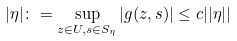Convert formula to latex. <formula><loc_0><loc_0><loc_500><loc_500>| \eta | \colon = \sup _ { z \in U , s \in S _ { \eta } } | g ( z , s ) | \leq c | | \eta | |</formula> 